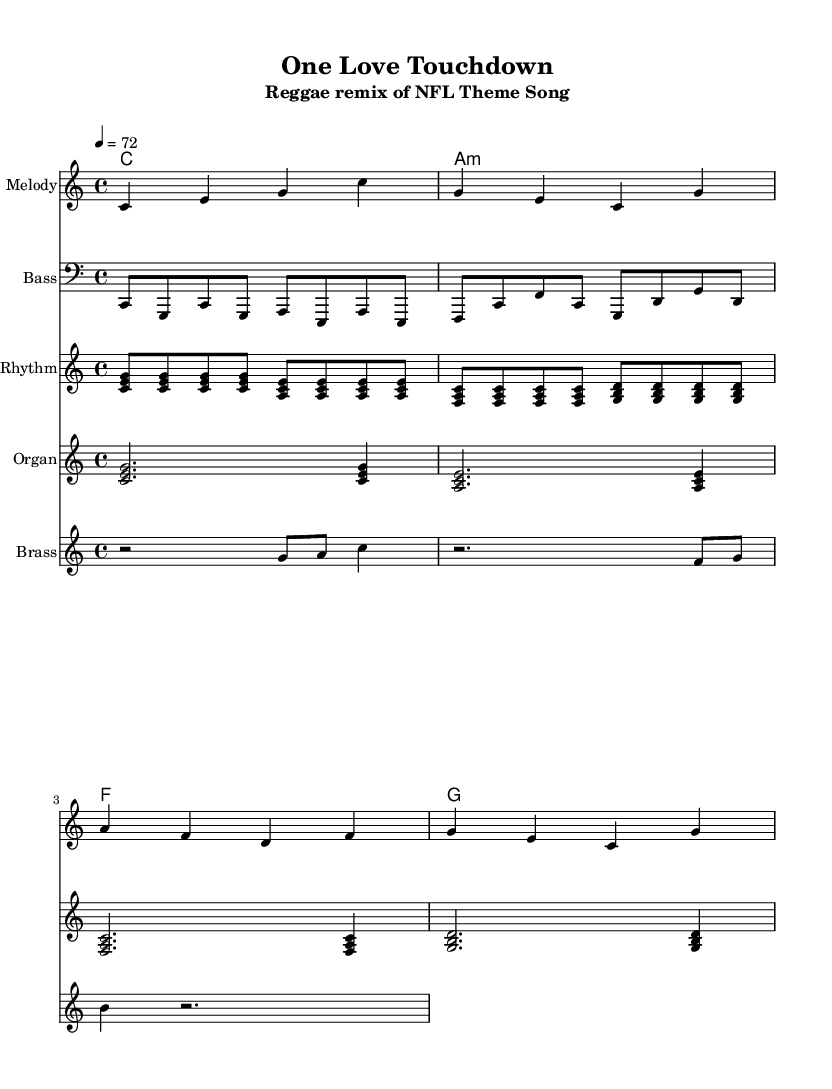What is the key signature of this music? The key signature is C major, which has no sharps or flats.
Answer: C major What is the time signature of this piece? The time signature is indicated as 4/4, meaning there are four beats per measure, and the quarter note gets one beat.
Answer: 4/4 What is the tempo marking of the composition? The tempo marking indicates a speed of 72 beats per minute, which defines how fast the piece should be played.
Answer: 72 Which instrument plays the melody? The melody is notated on the staff labeled "Melody," indicating the part specifically designated for that instrument.
Answer: Melody How many instruments are featured in this sheet music? There are a total of five instruments represented in the score: Melody, Bass, Rhythm, Organ, and Brass.
Answer: Five Identify a unique characteristic of reggae music in this piece. The use of offbeat rhythms, often emphasized by the rhythm guitar, is a characteristic common in reggae, contributing to its laid-back feel.
Answer: Offbeat rhythms What is the first chord played in the harmonic progression? The first chord listed in the chord section is C, indicating that the piece starts in the tonic chord of the key signature.
Answer: C 